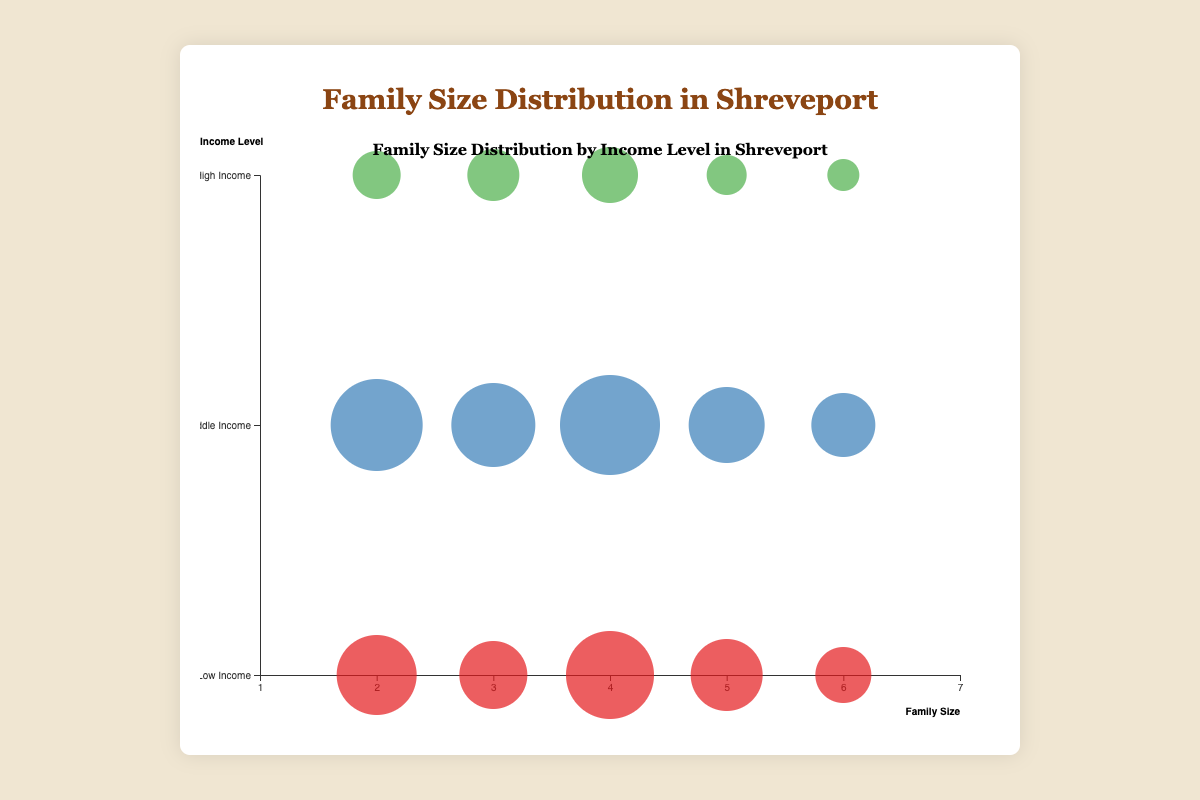Which family size has the most number of families in the Middle Income level? To find the size of the family with the most Middle Income families, look at the bubbles in the "Middle Income" row and compare their sizes. The largest bubble in this row is for family size 4, with 200 families.
Answer: Family size 4 What is the total number of Low Income families with a size of 2 or 3? Add the number of low-income families for family size 2 and family size 3. There are 150 families with a size of 2 and 120 families with a size of 3. 150 + 120 = 270.
Answer: 270 Which income level has more families with a size of 5, Low Income or High Income? Compare the sizes of the bubbles for the 5-family size in the Low Income and High Income rows. The size for Low Income is 130 families, while for High Income it is 50.
Answer: Low Income How many more families are there in the Middle Income group compared to the High Income group for family size 3? Subtract the number of High Income families from the number of Middle Income families for family size 3. Middle Income has 160 families, and High Income has 80 families. 160 - 80 = 80.
Answer: 80 What is the trend observed in the number of families as the family size increases for High Income families? Observing the trend in the sizes of the bubbles in the High Income row, as the family size increases from 2 to 6, the number of families generally decreases. Family size 2 has 70, size 3 has 80, size 4 has 90, size 5 has 50, and size 6 has 30.
Answer: Decreasing Which family size has the smallest number of families in the High Income level, and what is that number? Locate the smallest bubble in the High Income row. The smallest bubble corresponds to a family size of 6 with 30 families.
Answer: Family size 6, 30 families How many families are there in total for family sizes 2 and 4 in the Low Income group? Add the number of Low Income families for family sizes 2 and 4. There are 150 families for size 2 and 170 families for size 4. 150 + 170 = 320.
Answer: 320 Compare the number of Middle Income families with family sizes 2 and 5. Which is larger and by how much? Compare the bubbles for family sizes 2 and 5 in the Middle Income row. Family size 2 has 180 families, and size 5 has 140. The difference is 180 - 140 = 40.
Answer: Family size 2, by 40 What proportion of Low Income families have a size of 6 compared to the total Low Income families with size 5 or 6? Calculate the proportion by dividing the number of families with size 6 by the total number of families with size 5 and 6. Low Income families with size 6 are 90, and with size 5 are 130. Total = 90 + 130 = 220. Proportion = 90 / 220 ≈ 0.409.
Answer: Approximately 0.409 